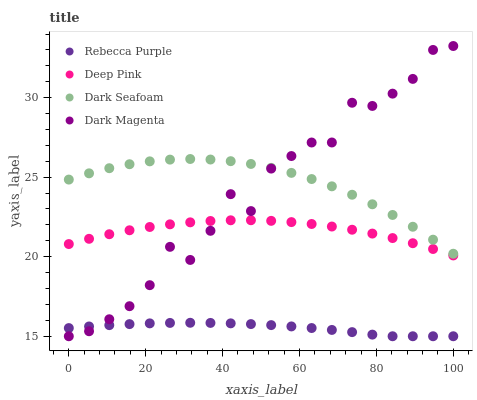Does Rebecca Purple have the minimum area under the curve?
Answer yes or no. Yes. Does Dark Seafoam have the maximum area under the curve?
Answer yes or no. Yes. Does Deep Pink have the minimum area under the curve?
Answer yes or no. No. Does Deep Pink have the maximum area under the curve?
Answer yes or no. No. Is Rebecca Purple the smoothest?
Answer yes or no. Yes. Is Dark Magenta the roughest?
Answer yes or no. Yes. Is Deep Pink the smoothest?
Answer yes or no. No. Is Deep Pink the roughest?
Answer yes or no. No. Does Rebecca Purple have the lowest value?
Answer yes or no. Yes. Does Deep Pink have the lowest value?
Answer yes or no. No. Does Dark Magenta have the highest value?
Answer yes or no. Yes. Does Deep Pink have the highest value?
Answer yes or no. No. Is Deep Pink less than Dark Seafoam?
Answer yes or no. Yes. Is Dark Seafoam greater than Deep Pink?
Answer yes or no. Yes. Does Rebecca Purple intersect Dark Magenta?
Answer yes or no. Yes. Is Rebecca Purple less than Dark Magenta?
Answer yes or no. No. Is Rebecca Purple greater than Dark Magenta?
Answer yes or no. No. Does Deep Pink intersect Dark Seafoam?
Answer yes or no. No. 